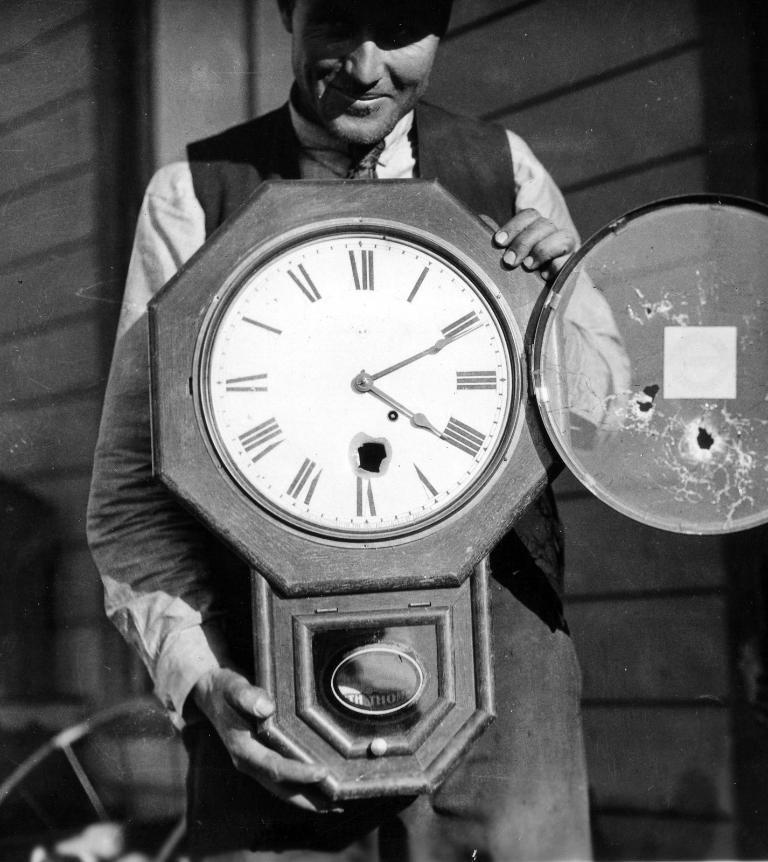<image>
Give a short and clear explanation of the subsequent image. A large broken clock being held by a man is set to 4:11. 